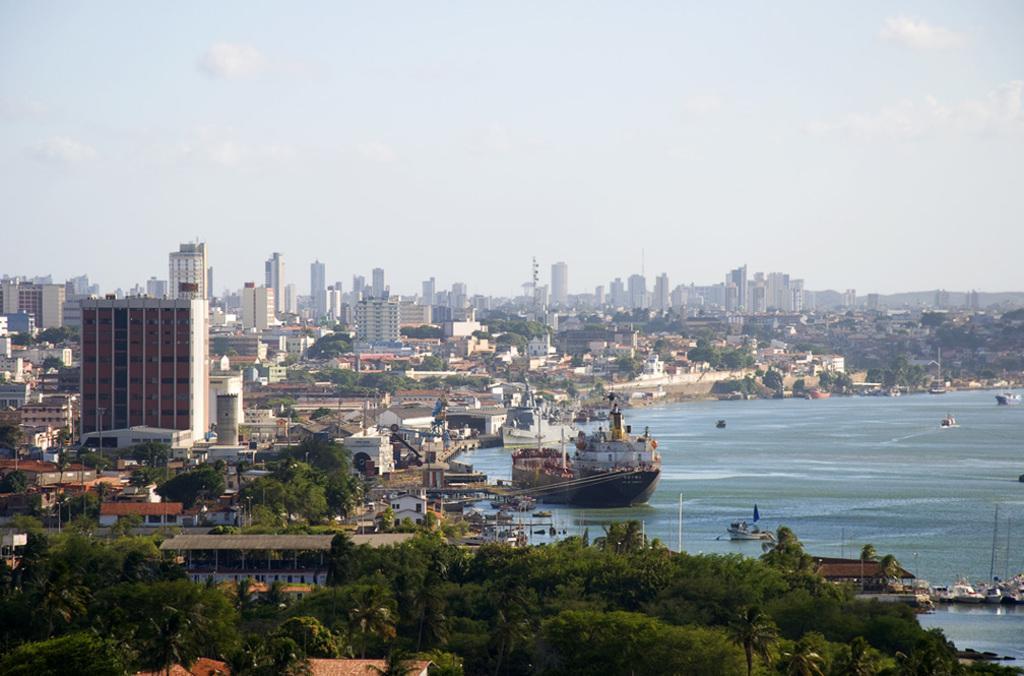Could you give a brief overview of what you see in this image? In this picture we can see water on the right side, there is a ship and some boats in the water, at the bottom there are some trees, we can see buildings and trees in the background, there is the sky at the top of the picture, on the left side we can see some poles. 